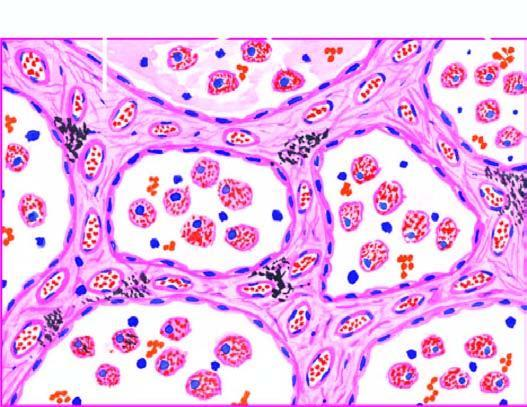what do the alveolar lumina contain?
Answer the question using a single word or phrase. Heart failure cells (alveolar macrophages containing haemosiderin pigment) 